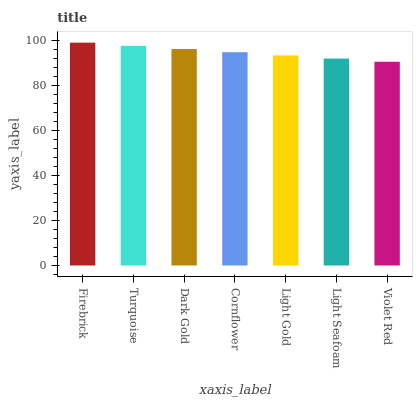Is Violet Red the minimum?
Answer yes or no. Yes. Is Firebrick the maximum?
Answer yes or no. Yes. Is Turquoise the minimum?
Answer yes or no. No. Is Turquoise the maximum?
Answer yes or no. No. Is Firebrick greater than Turquoise?
Answer yes or no. Yes. Is Turquoise less than Firebrick?
Answer yes or no. Yes. Is Turquoise greater than Firebrick?
Answer yes or no. No. Is Firebrick less than Turquoise?
Answer yes or no. No. Is Cornflower the high median?
Answer yes or no. Yes. Is Cornflower the low median?
Answer yes or no. Yes. Is Firebrick the high median?
Answer yes or no. No. Is Light Seafoam the low median?
Answer yes or no. No. 